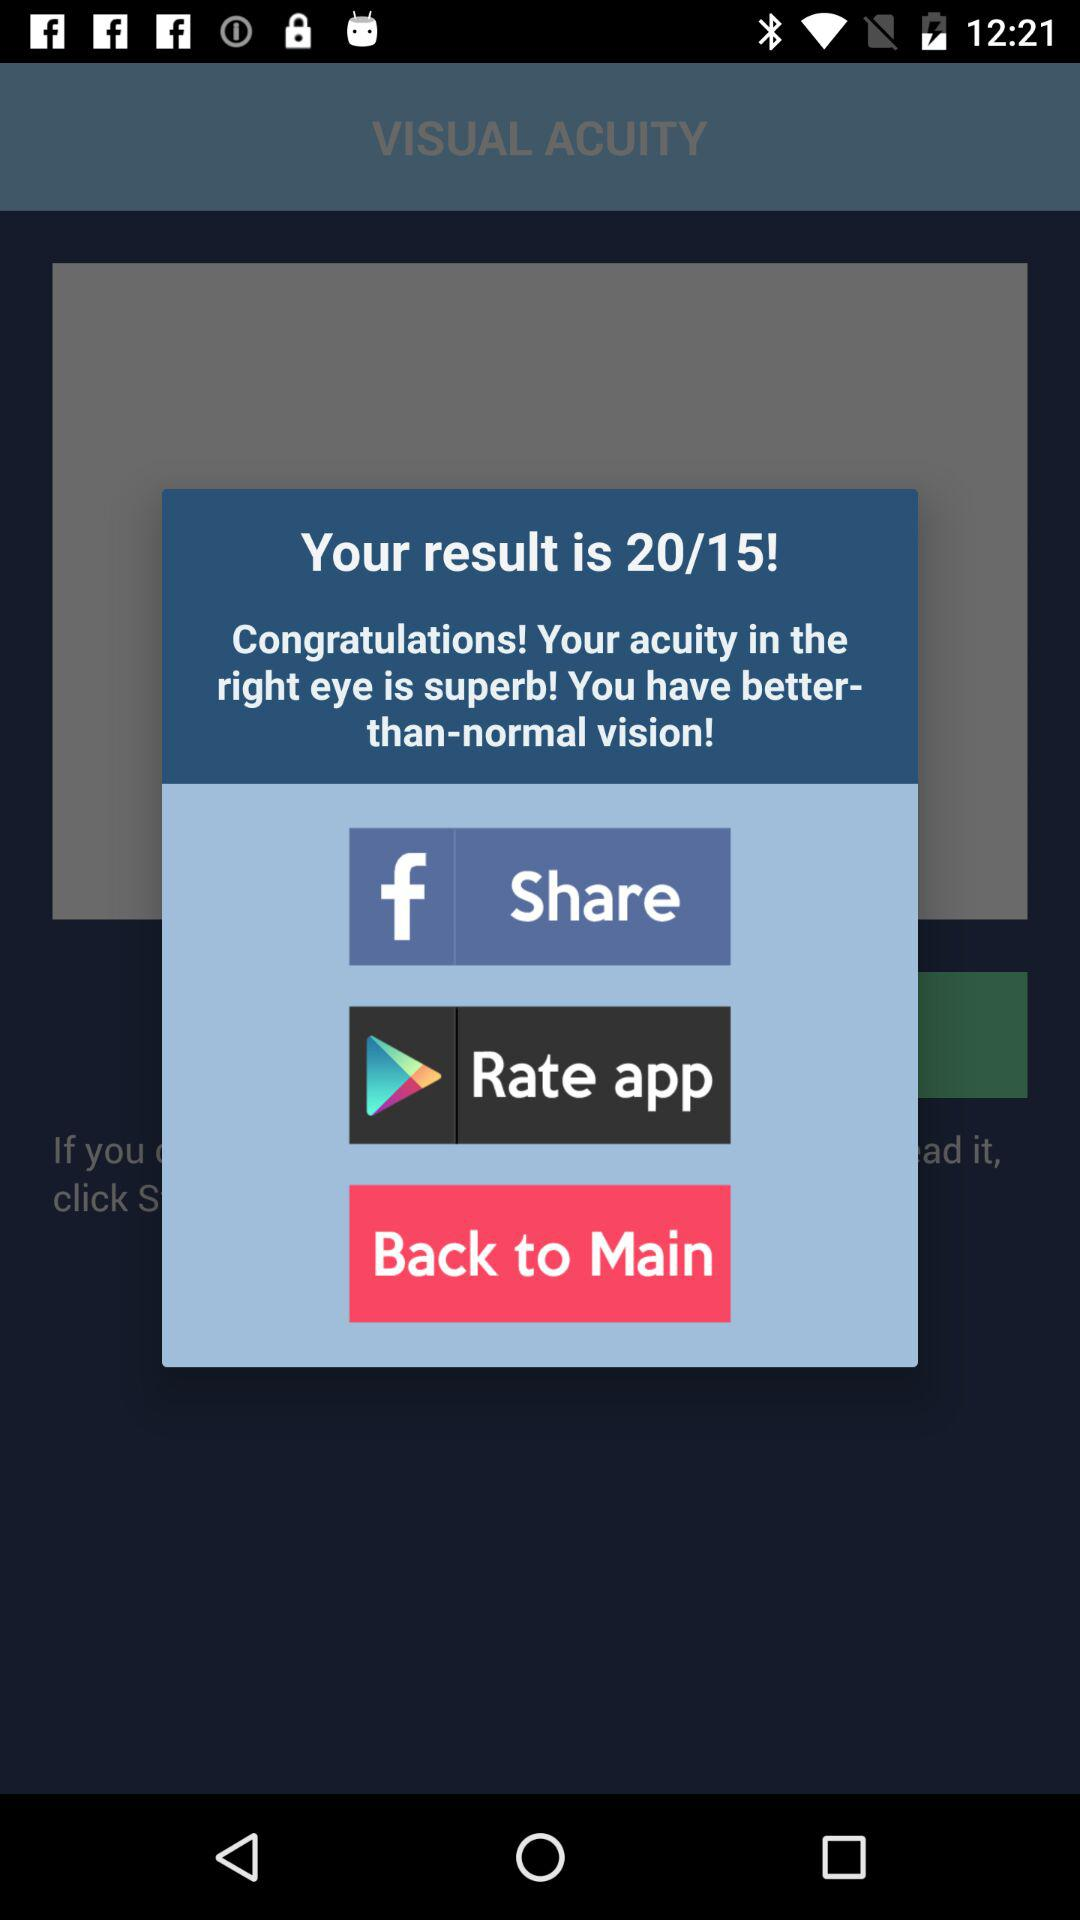Through which applications can we share? You can share it through Facebook. 